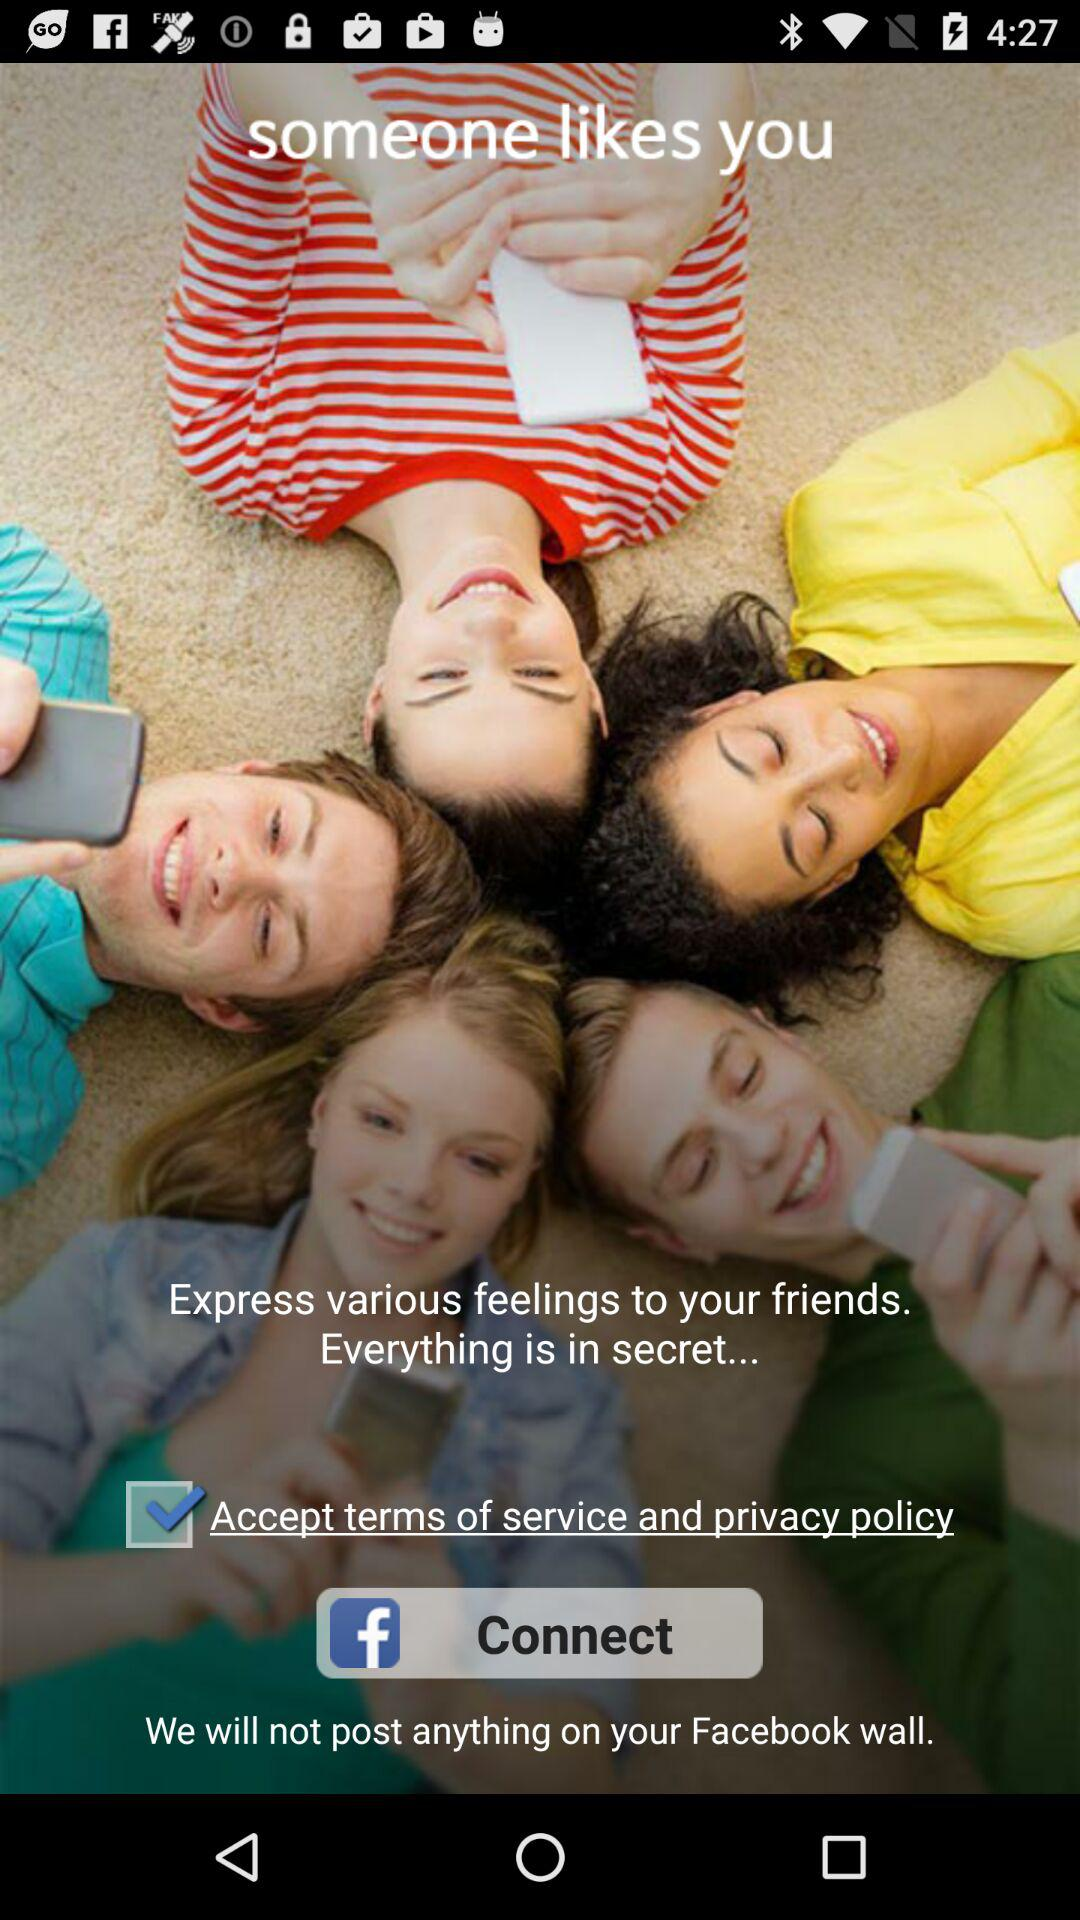Is "Accept terms of service and privacy policy" checked or unchecked? "Accept terms of service and privacy policy" is checked. 